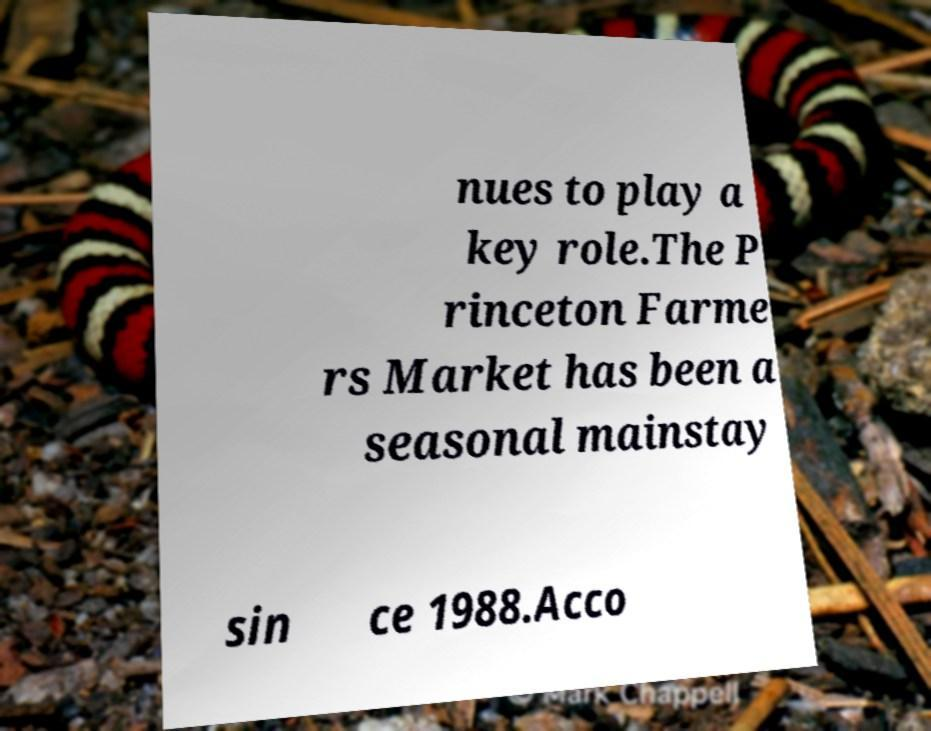Could you extract and type out the text from this image? nues to play a key role.The P rinceton Farme rs Market has been a seasonal mainstay sin ce 1988.Acco 